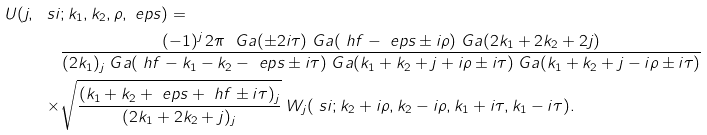Convert formula to latex. <formula><loc_0><loc_0><loc_500><loc_500>U ( j , \ s i & ; k _ { 1 } , k _ { 2 } , \rho , \ e p s ) = \\ & \frac { ( - 1 ) ^ { j } \, 2 \pi \ \ G a ( \pm 2 i \tau ) \ G a ( \ h f - \ e p s \pm i \rho ) \ G a ( 2 k _ { 1 } + 2 k _ { 2 } + 2 j ) } { ( 2 k _ { 1 } ) _ { j } \ G a ( \ h f - k _ { 1 } - k _ { 2 } - \ e p s \pm i \tau ) \ G a ( k _ { 1 } + k _ { 2 } + j + i \rho \pm i \tau ) \ G a ( k _ { 1 } + k _ { 2 } + j - i \rho \pm i \tau ) } \\ \times & \sqrt { \frac { ( k _ { 1 } + k _ { 2 } + \ e p s + \ h f \pm i \tau ) _ { j } } { ( 2 k _ { 1 } + 2 k _ { 2 } + j ) _ { j } } } \ W _ { j } ( \ s i ; k _ { 2 } + i \rho , k _ { 2 } - i \rho , k _ { 1 } + i \tau , k _ { 1 } - i \tau ) .</formula> 